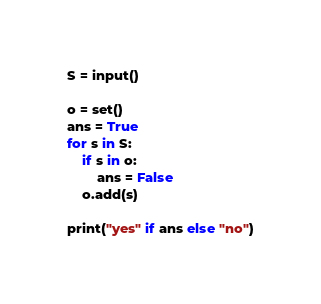Convert code to text. <code><loc_0><loc_0><loc_500><loc_500><_Python_>S = input()

o = set()
ans = True
for s in S:
    if s in o:
        ans = False
    o.add(s)

print("yes" if ans else "no")
</code> 